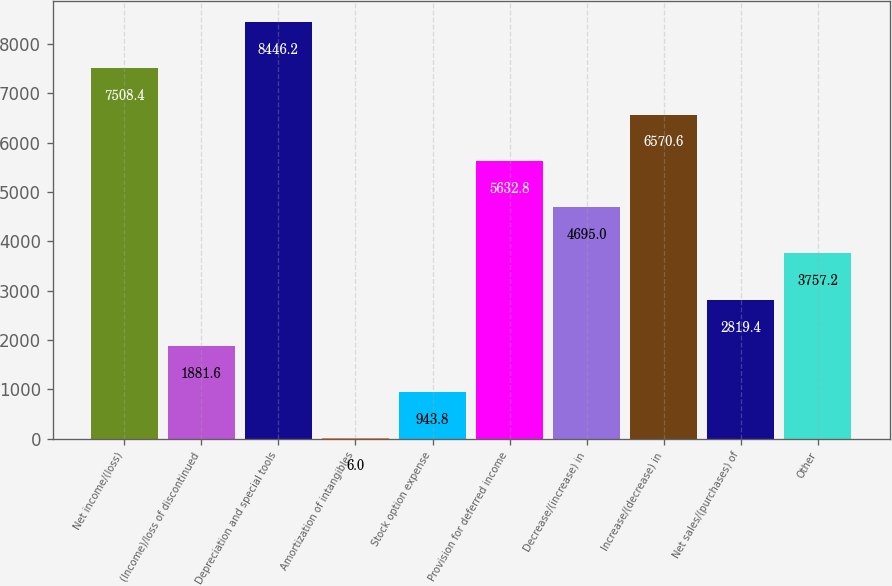<chart> <loc_0><loc_0><loc_500><loc_500><bar_chart><fcel>Net income/(loss)<fcel>(Income)/loss of discontinued<fcel>Depreciation and special tools<fcel>Amortization of intangibles<fcel>Stock option expense<fcel>Provision for deferred income<fcel>Decrease/(increase) in<fcel>Increase/(decrease) in<fcel>Net sales/(purchases) of<fcel>Other<nl><fcel>7508.4<fcel>1881.6<fcel>8446.2<fcel>6<fcel>943.8<fcel>5632.8<fcel>4695<fcel>6570.6<fcel>2819.4<fcel>3757.2<nl></chart> 